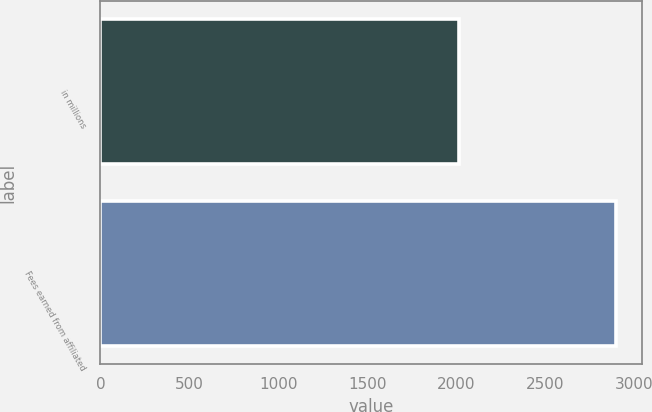<chart> <loc_0><loc_0><loc_500><loc_500><bar_chart><fcel>in millions<fcel>Fees earned from affiliated<nl><fcel>2013<fcel>2897<nl></chart> 